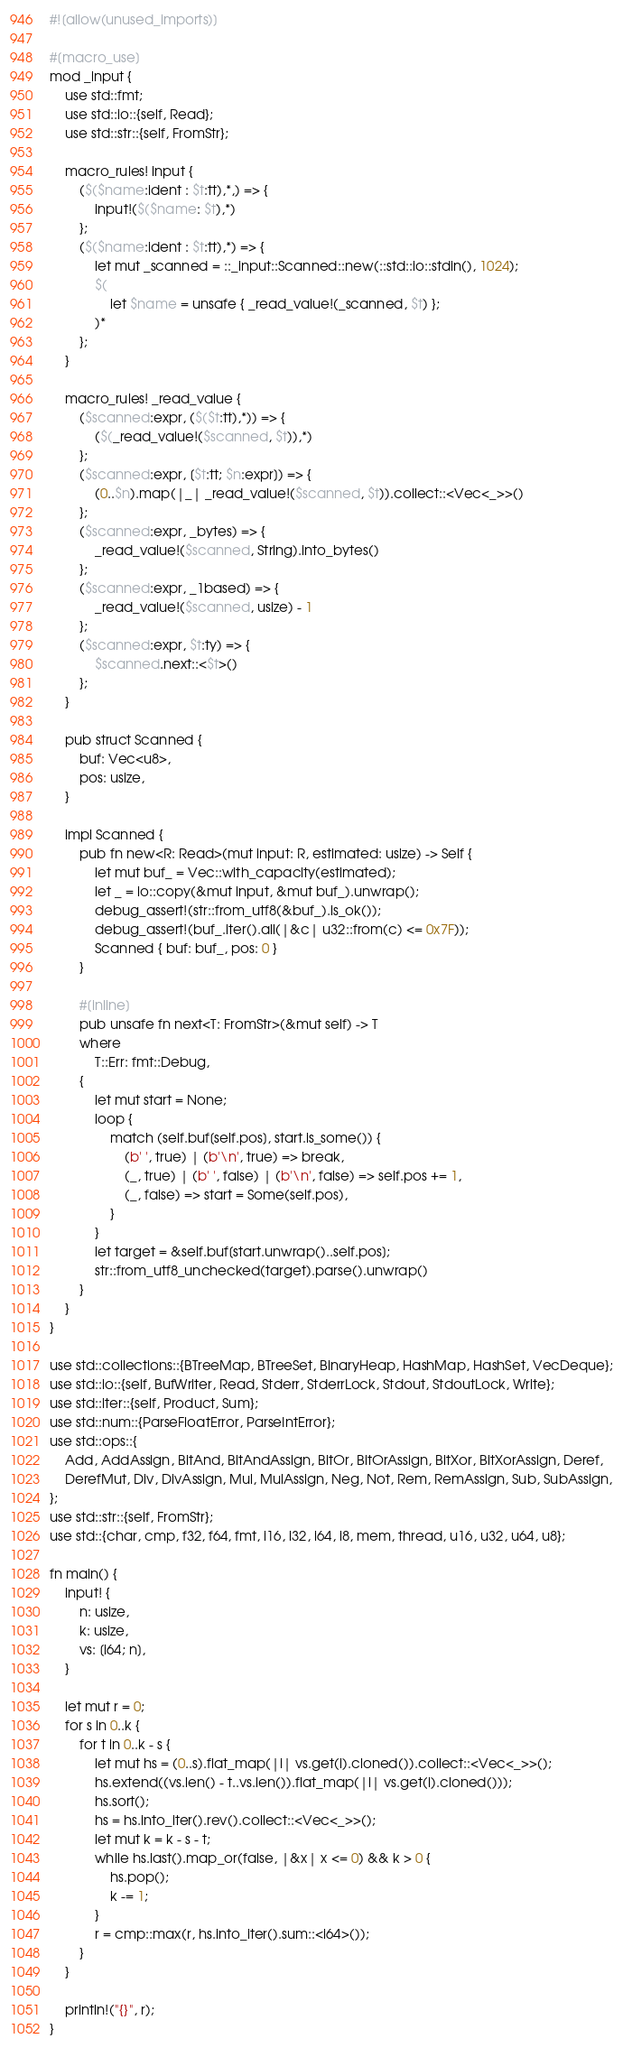Convert code to text. <code><loc_0><loc_0><loc_500><loc_500><_Rust_>#![allow(unused_imports)]

#[macro_use]
mod _input {
    use std::fmt;
    use std::io::{self, Read};
    use std::str::{self, FromStr};

    macro_rules! input {
        ($($name:ident : $t:tt),*,) => {
            input!($($name: $t),*)
        };
        ($($name:ident : $t:tt),*) => {
            let mut _scanned = ::_input::Scanned::new(::std::io::stdin(), 1024);
            $(
                let $name = unsafe { _read_value!(_scanned, $t) };
            )*
        };
    }

    macro_rules! _read_value {
        ($scanned:expr, ($($t:tt),*)) => {
            ($(_read_value!($scanned, $t)),*)
        };
        ($scanned:expr, [$t:tt; $n:expr]) => {
            (0..$n).map(|_| _read_value!($scanned, $t)).collect::<Vec<_>>()
        };
        ($scanned:expr, _bytes) => {
            _read_value!($scanned, String).into_bytes()
        };
        ($scanned:expr, _1based) => {
            _read_value!($scanned, usize) - 1
        };
        ($scanned:expr, $t:ty) => {
            $scanned.next::<$t>()
        };
    }

    pub struct Scanned {
        buf: Vec<u8>,
        pos: usize,
    }

    impl Scanned {
        pub fn new<R: Read>(mut input: R, estimated: usize) -> Self {
            let mut buf_ = Vec::with_capacity(estimated);
            let _ = io::copy(&mut input, &mut buf_).unwrap();
            debug_assert!(str::from_utf8(&buf_).is_ok());
            debug_assert!(buf_.iter().all(|&c| u32::from(c) <= 0x7F));
            Scanned { buf: buf_, pos: 0 }
        }

        #[inline]
        pub unsafe fn next<T: FromStr>(&mut self) -> T
        where
            T::Err: fmt::Debug,
        {
            let mut start = None;
            loop {
                match (self.buf[self.pos], start.is_some()) {
                    (b' ', true) | (b'\n', true) => break,
                    (_, true) | (b' ', false) | (b'\n', false) => self.pos += 1,
                    (_, false) => start = Some(self.pos),
                }
            }
            let target = &self.buf[start.unwrap()..self.pos];
            str::from_utf8_unchecked(target).parse().unwrap()
        }
    }
}

use std::collections::{BTreeMap, BTreeSet, BinaryHeap, HashMap, HashSet, VecDeque};
use std::io::{self, BufWriter, Read, Stderr, StderrLock, Stdout, StdoutLock, Write};
use std::iter::{self, Product, Sum};
use std::num::{ParseFloatError, ParseIntError};
use std::ops::{
    Add, AddAssign, BitAnd, BitAndAssign, BitOr, BitOrAssign, BitXor, BitXorAssign, Deref,
    DerefMut, Div, DivAssign, Mul, MulAssign, Neg, Not, Rem, RemAssign, Sub, SubAssign,
};
use std::str::{self, FromStr};
use std::{char, cmp, f32, f64, fmt, i16, i32, i64, i8, mem, thread, u16, u32, u64, u8};

fn main() {
    input! {
        n: usize,
        k: usize,
        vs: [i64; n],
    }

    let mut r = 0;
    for s in 0..k {
        for t in 0..k - s {
            let mut hs = (0..s).flat_map(|i| vs.get(i).cloned()).collect::<Vec<_>>();
            hs.extend((vs.len() - t..vs.len()).flat_map(|i| vs.get(i).cloned()));
            hs.sort();
            hs = hs.into_iter().rev().collect::<Vec<_>>();
            let mut k = k - s - t;
            while hs.last().map_or(false, |&x| x <= 0) && k > 0 {
                hs.pop();
                k -= 1;
            }
            r = cmp::max(r, hs.into_iter().sum::<i64>());
        }
    }

    println!("{}", r);
}
</code> 